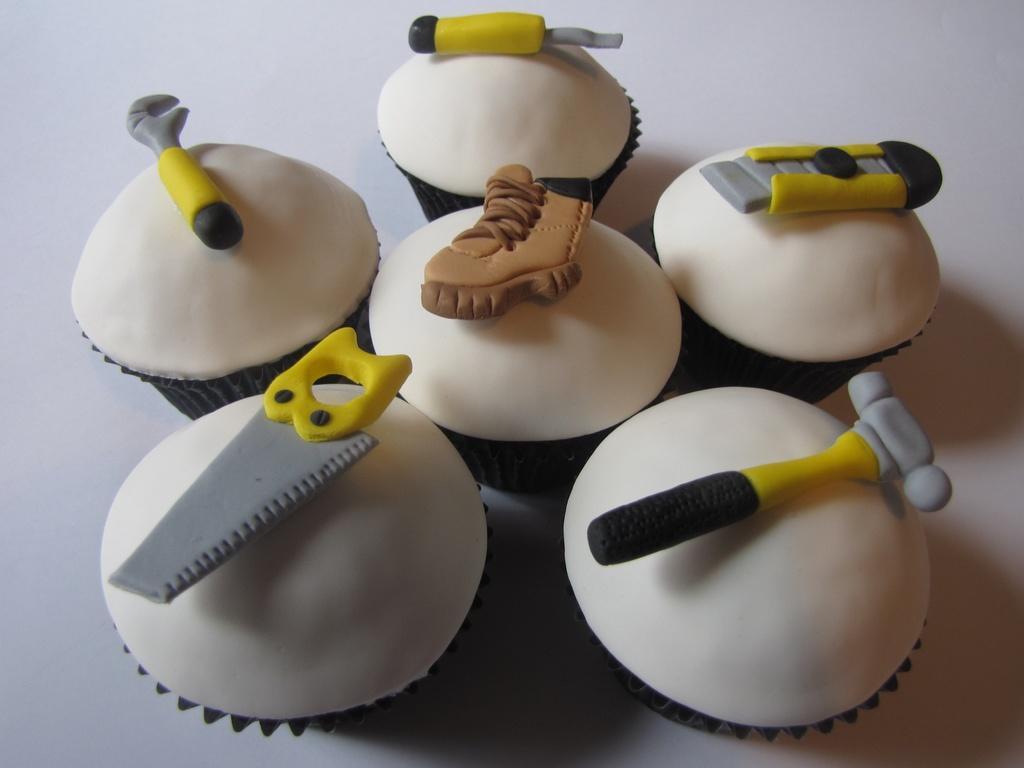Describe this image in one or two sentences. In this picture we can see cupcakes on the surface. On the top of the cupcakes we can see tools and a shoe like structured food items. 